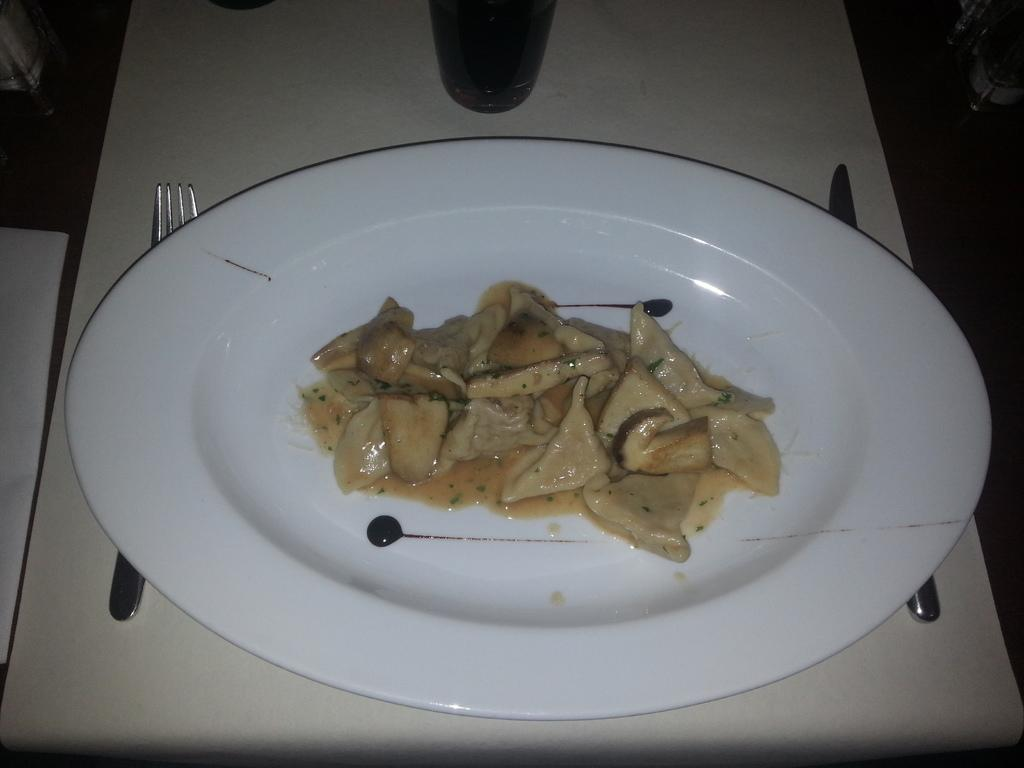What piece of furniture is present in the image? There is a table in the image. What is placed on the table? There is a plate, a glass, a fork, and a knife on the table. What is in the plate? There is food in the plate. What type of stick is used to maintain the relation between the objects on the table? There is no stick present in the image, and the objects on the table are not connected by any relation that requires a stick. 